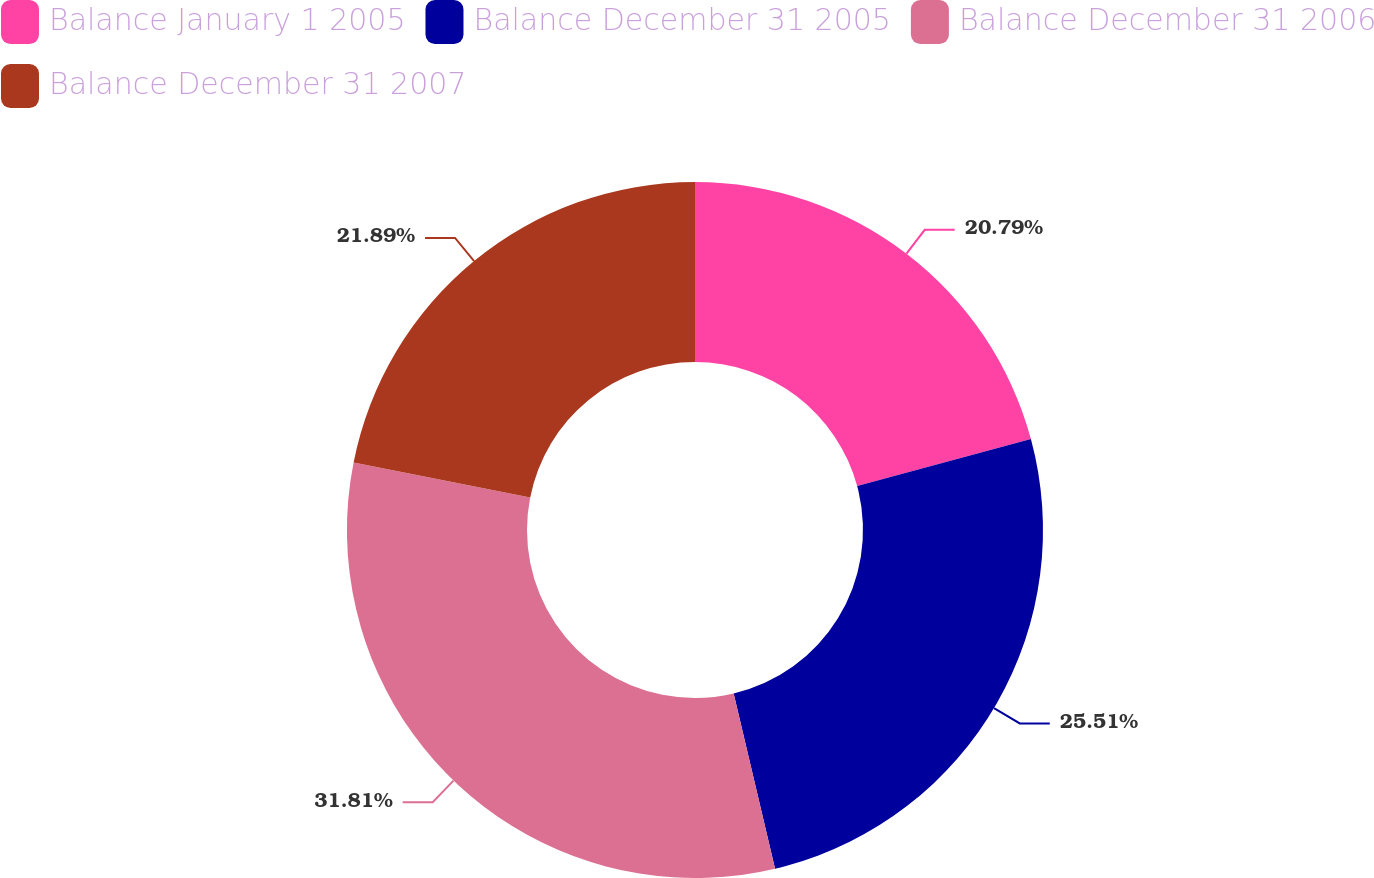Convert chart. <chart><loc_0><loc_0><loc_500><loc_500><pie_chart><fcel>Balance January 1 2005<fcel>Balance December 31 2005<fcel>Balance December 31 2006<fcel>Balance December 31 2007<nl><fcel>20.79%<fcel>25.51%<fcel>31.8%<fcel>21.89%<nl></chart> 